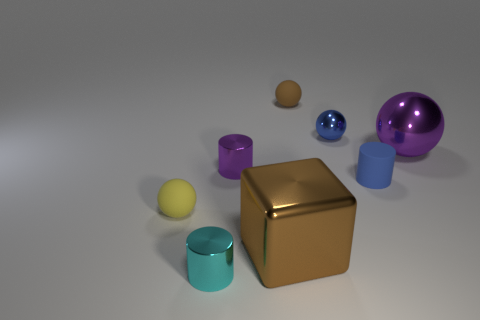How would you describe the arrangement of objects in this image? The objects are scattered across a flat surface with no specific pattern, featuring different shapes like cylinders, spheres, and a cube. They appear to be placed without any discernible order, giving the scene a random and relaxed aesthetic. 